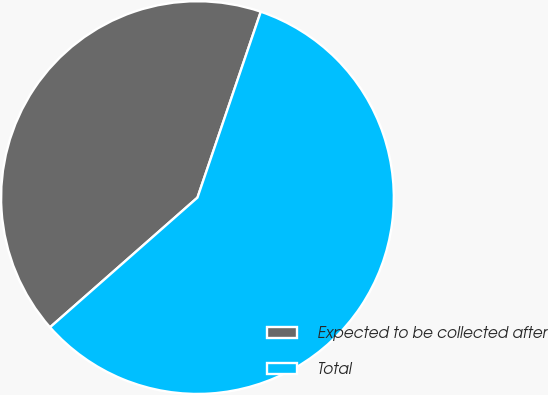Convert chart. <chart><loc_0><loc_0><loc_500><loc_500><pie_chart><fcel>Expected to be collected after<fcel>Total<nl><fcel>41.71%<fcel>58.29%<nl></chart> 